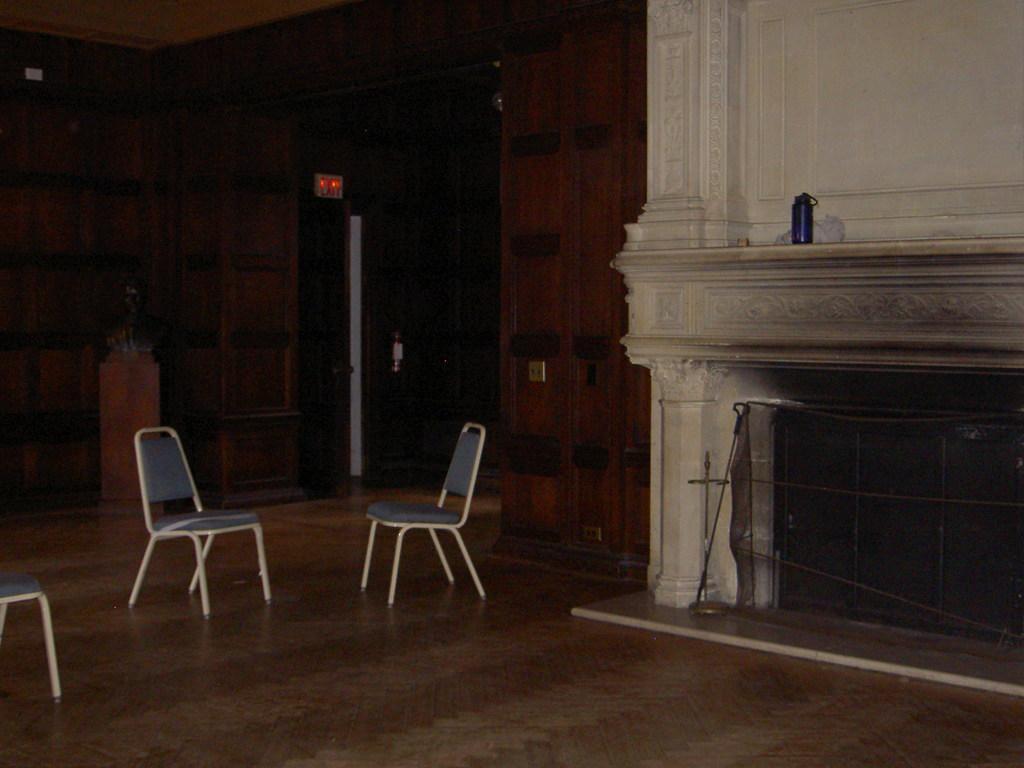Can you describe this image briefly? In this image there is floor at the bottom. There is a chair on the left corner. There are chairs in the foreground. There is an object on the wall, there are objects in the right corner. There are objects, it looks like a wall in the background. 